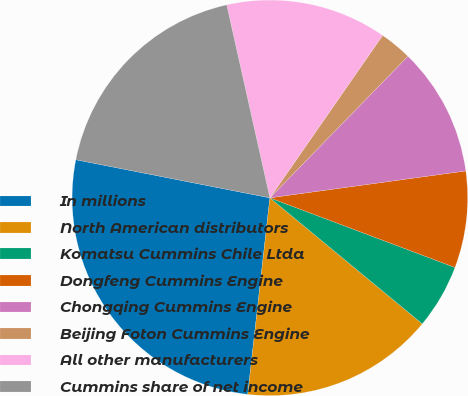<chart> <loc_0><loc_0><loc_500><loc_500><pie_chart><fcel>In millions<fcel>North American distributors<fcel>Komatsu Cummins Chile Ltda<fcel>Dongfeng Cummins Engine<fcel>Chongqing Cummins Engine<fcel>Beijing Foton Cummins Engine<fcel>All other manufacturers<fcel>Cummins share of net income<nl><fcel>26.3%<fcel>15.79%<fcel>5.27%<fcel>7.9%<fcel>10.53%<fcel>2.64%<fcel>13.16%<fcel>18.41%<nl></chart> 